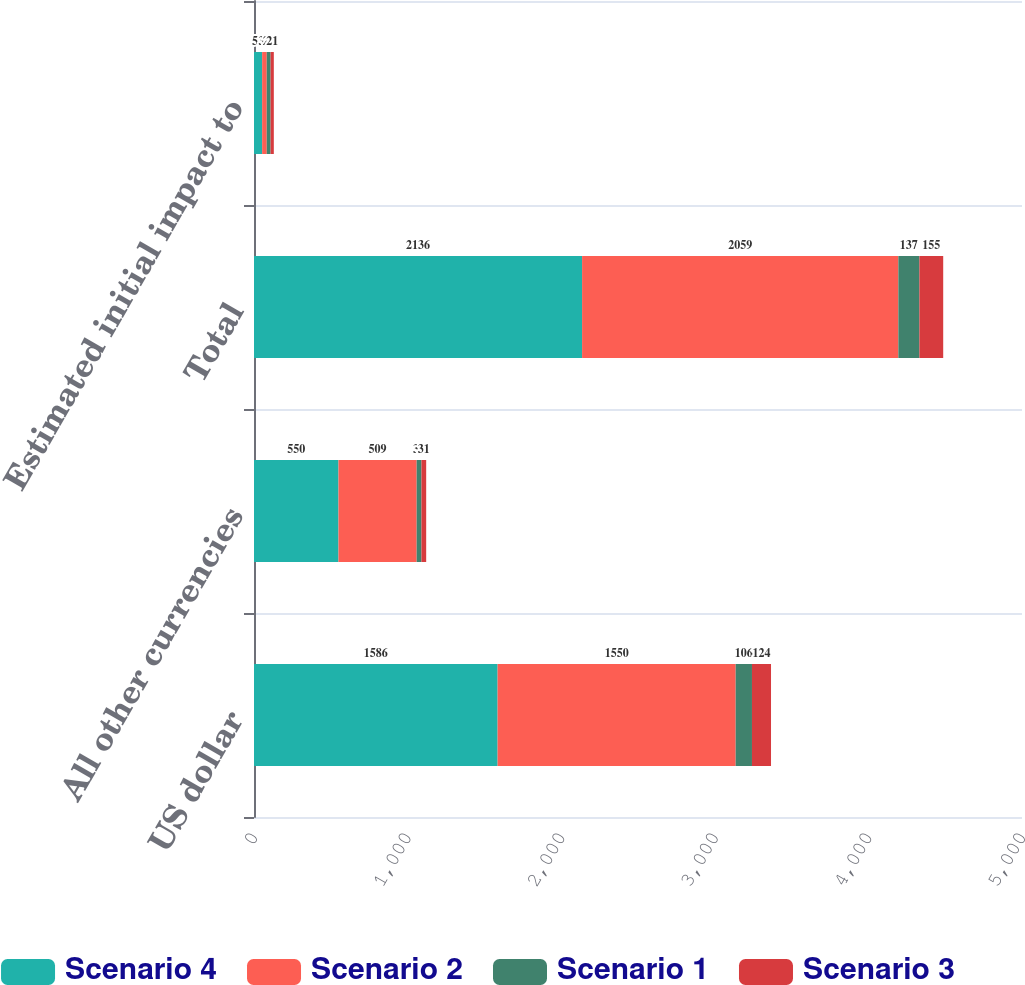Convert chart. <chart><loc_0><loc_0><loc_500><loc_500><stacked_bar_chart><ecel><fcel>US dollar<fcel>All other currencies<fcel>Total<fcel>Estimated initial impact to<nl><fcel>Scenario 4<fcel>1586<fcel>550<fcel>2136<fcel>53<nl><fcel>Scenario 2<fcel>1550<fcel>509<fcel>2059<fcel>30<nl><fcel>Scenario 1<fcel>106<fcel>31<fcel>137<fcel>25<nl><fcel>Scenario 3<fcel>124<fcel>31<fcel>155<fcel>21<nl></chart> 